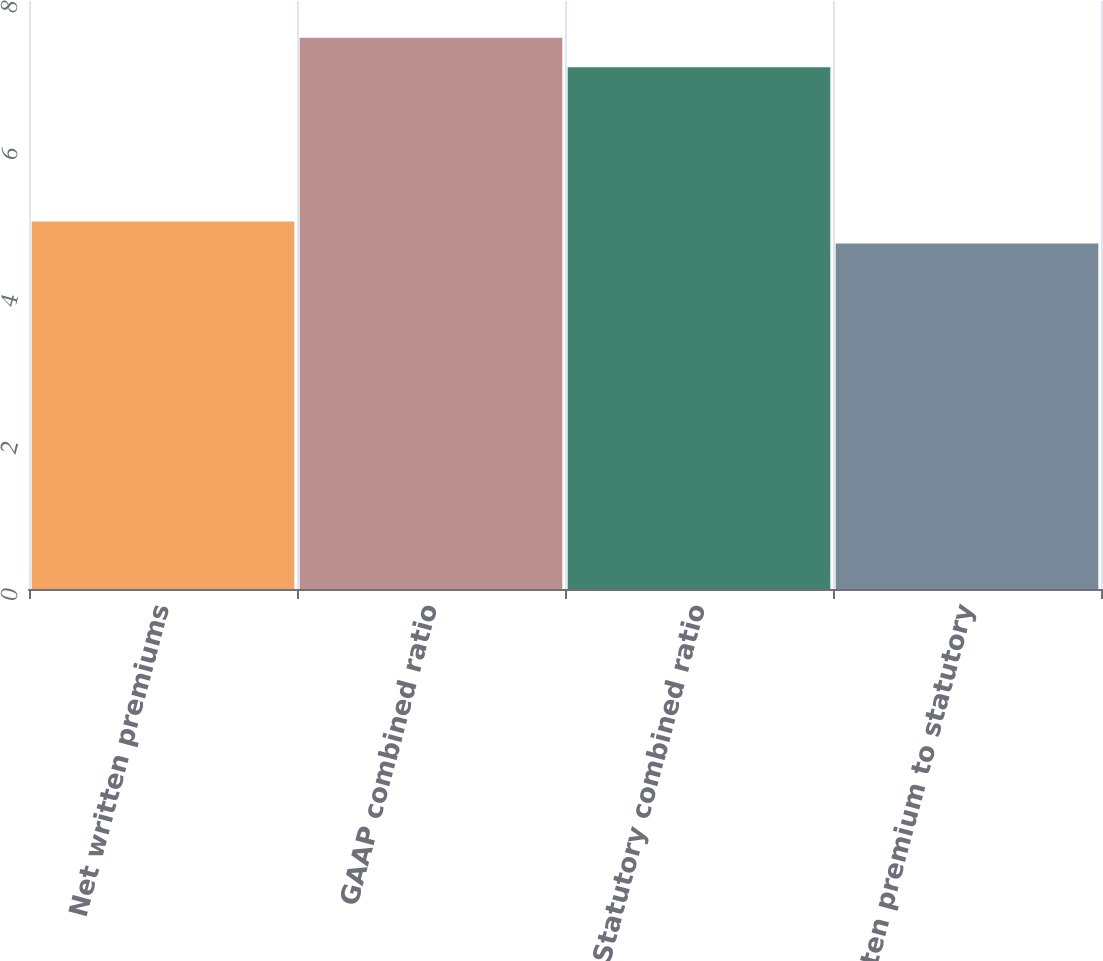<chart> <loc_0><loc_0><loc_500><loc_500><bar_chart><fcel>Net written premiums<fcel>GAAP combined ratio<fcel>Statutory combined ratio<fcel>Written premium to statutory<nl><fcel>5<fcel>7.5<fcel>7.1<fcel>4.7<nl></chart> 